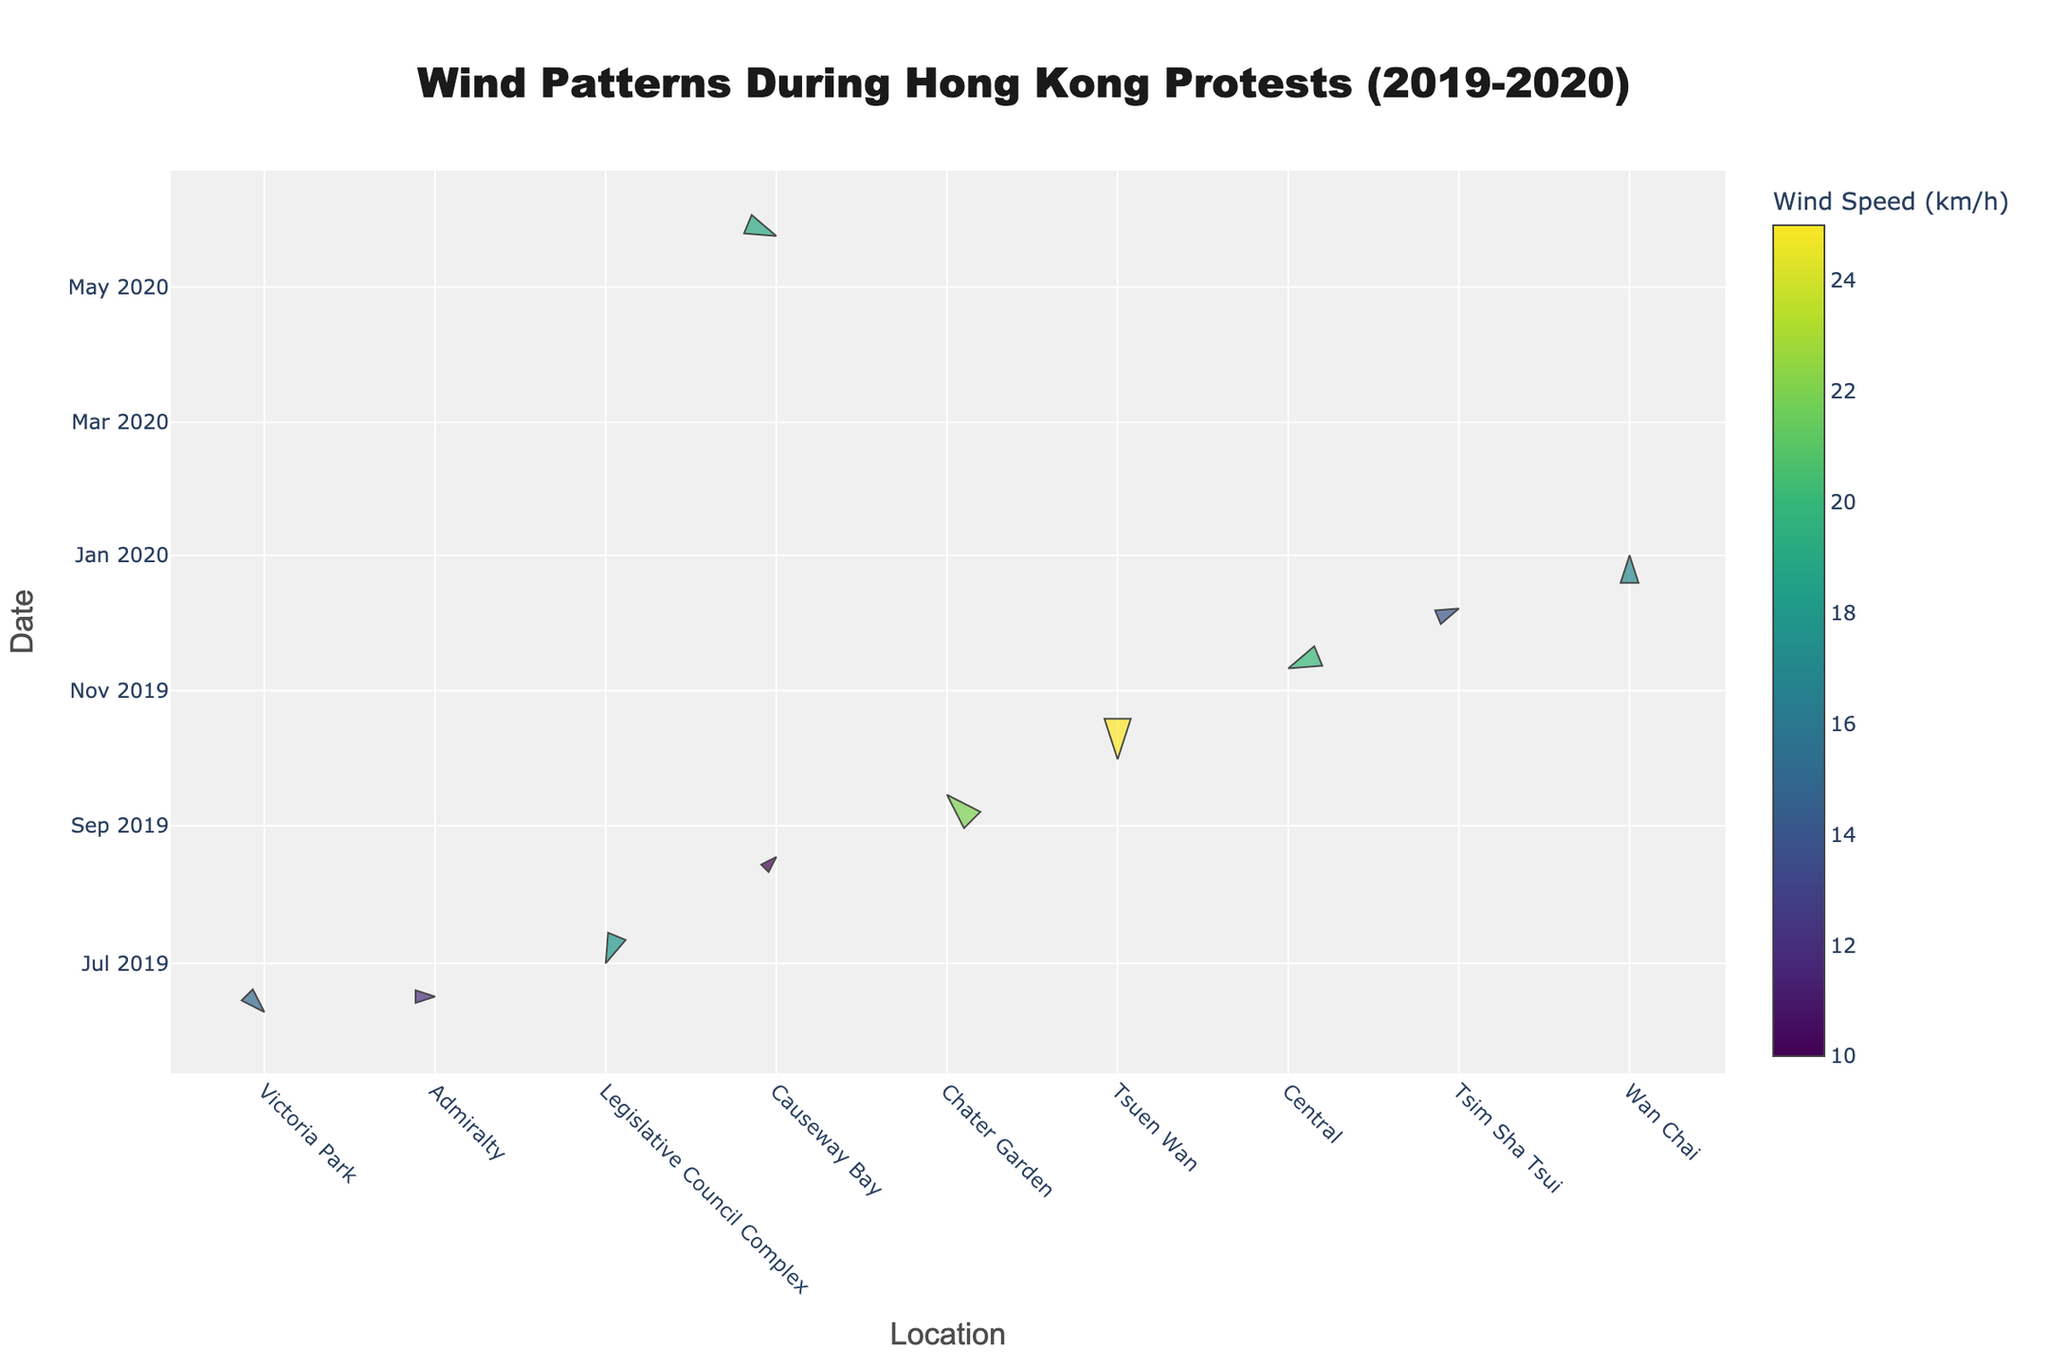what is the title of the figure? The title of the figure is located at the top of the chart and is usually highlighted with a larger font compared to other text. By examining the chart, the title can be clearly read.
Answer: Wind Patterns During Hong Kong Protests (2019-2020) How many protests are shown in the figure? Count the number of unique events listed in the data points on the chart. Each event corresponds to a specific plot point.
Answer: 10 What is the wind direction and wind speed during the Anti-Extradition Bill Protest at Victoria Park? Look for the event "Anti-Extradition Bill Protest" at Victoria Park in the figure and read off the wind direction and speed corresponding to this event.
Answer: SE, 15 km/h Which protest had the highest wind speed recorded? Identify the data point with the largest marker size and color indicating the highest wind speed. The event name will be displayed in the hover text or associated label.
Answer: National Day Protests at Tsuen Wan Compare the wind speeds during the Two Million March and the Human Rights Day March. Which protest experienced higher wind speed? Locate both events on the chart and compare the wind speed values displayed as marker sizes and colors. The higher wind speed will be indicated by a larger marker size and more intense color.
Answer: Human Rights Day March (14 km/h) Which event had the wind coming from the south? Find the data point where the wind direction is 'S' and read off the event associated with that.
Answer: National Day Protests at Tsuen Wan What was the wind speed and direction during the National Security Law Protest? Locate the "National Security Law Protest" event in the figure, and then read off the wind speed and direction displayed for that event.
Answer: ESE, 19 km/h During which protest at Causeway Bay did the wind blow from the northeast? Identify both instances at Causeway Bay and check their wind directions. Select the protest during which the wind direction was 'NE'.
Answer: Victoria Park Rally on August 18 Which protest had the wind blowing from the northwest at a speed of 22 km/h? Find the data point with wind direction 'NW' and a wind speed of 22 km/h, and read off the event name displayed for that data point.
Answer: Rally to the US Consulate at Chater Garden 